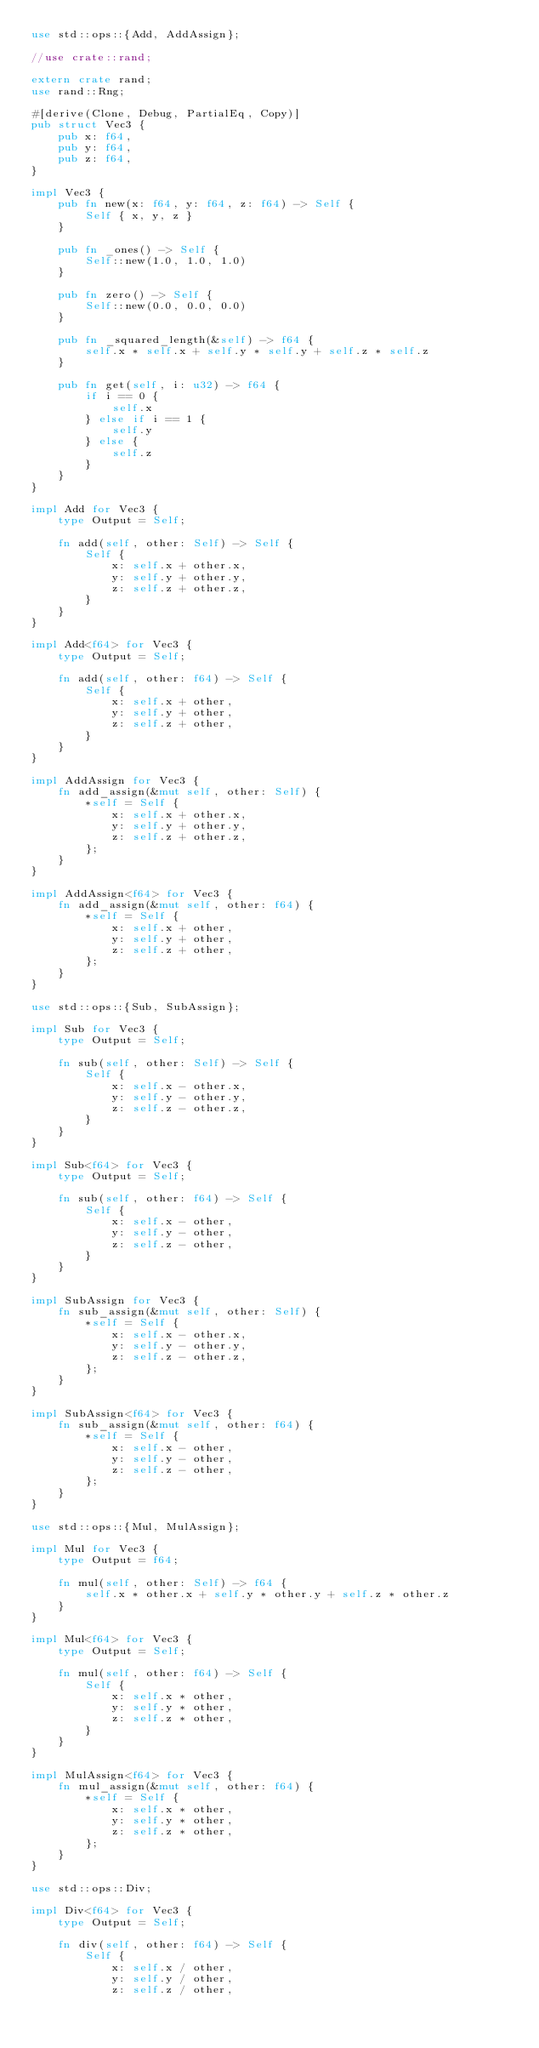<code> <loc_0><loc_0><loc_500><loc_500><_Rust_>use std::ops::{Add, AddAssign};

//use crate::rand;

extern crate rand;
use rand::Rng;

#[derive(Clone, Debug, PartialEq, Copy)]
pub struct Vec3 {
    pub x: f64,
    pub y: f64,
    pub z: f64,
}

impl Vec3 {
    pub fn new(x: f64, y: f64, z: f64) -> Self {
        Self { x, y, z }
    }

    pub fn _ones() -> Self {
        Self::new(1.0, 1.0, 1.0)
    }

    pub fn zero() -> Self {
        Self::new(0.0, 0.0, 0.0)
    }

    pub fn _squared_length(&self) -> f64 {
        self.x * self.x + self.y * self.y + self.z * self.z
    }

    pub fn get(self, i: u32) -> f64 {
        if i == 0 {
            self.x
        } else if i == 1 {
            self.y
        } else {
            self.z
        }
    }
}

impl Add for Vec3 {
    type Output = Self;

    fn add(self, other: Self) -> Self {
        Self {
            x: self.x + other.x,
            y: self.y + other.y,
            z: self.z + other.z,
        }
    }
}

impl Add<f64> for Vec3 {
    type Output = Self;

    fn add(self, other: f64) -> Self {
        Self {
            x: self.x + other,
            y: self.y + other,
            z: self.z + other,
        }
    }
}

impl AddAssign for Vec3 {
    fn add_assign(&mut self, other: Self) {
        *self = Self {
            x: self.x + other.x,
            y: self.y + other.y,
            z: self.z + other.z,
        };
    }
}

impl AddAssign<f64> for Vec3 {
    fn add_assign(&mut self, other: f64) {
        *self = Self {
            x: self.x + other,
            y: self.y + other,
            z: self.z + other,
        };
    }
}

use std::ops::{Sub, SubAssign};

impl Sub for Vec3 {
    type Output = Self;

    fn sub(self, other: Self) -> Self {
        Self {
            x: self.x - other.x,
            y: self.y - other.y,
            z: self.z - other.z,
        }
    }
}

impl Sub<f64> for Vec3 {
    type Output = Self;

    fn sub(self, other: f64) -> Self {
        Self {
            x: self.x - other,
            y: self.y - other,
            z: self.z - other,
        }
    }
}

impl SubAssign for Vec3 {
    fn sub_assign(&mut self, other: Self) {
        *self = Self {
            x: self.x - other.x,
            y: self.y - other.y,
            z: self.z - other.z,
        };
    }
}

impl SubAssign<f64> for Vec3 {
    fn sub_assign(&mut self, other: f64) {
        *self = Self {
            x: self.x - other,
            y: self.y - other,
            z: self.z - other,
        };
    }
}

use std::ops::{Mul, MulAssign};

impl Mul for Vec3 {
    type Output = f64;

    fn mul(self, other: Self) -> f64 {
        self.x * other.x + self.y * other.y + self.z * other.z
    }
}

impl Mul<f64> for Vec3 {
    type Output = Self;

    fn mul(self, other: f64) -> Self {
        Self {
            x: self.x * other,
            y: self.y * other,
            z: self.z * other,
        }
    }
}

impl MulAssign<f64> for Vec3 {
    fn mul_assign(&mut self, other: f64) {
        *self = Self {
            x: self.x * other,
            y: self.y * other,
            z: self.z * other,
        };
    }
}

use std::ops::Div;

impl Div<f64> for Vec3 {
    type Output = Self;

    fn div(self, other: f64) -> Self {
        Self {
            x: self.x / other,
            y: self.y / other,
            z: self.z / other,</code> 